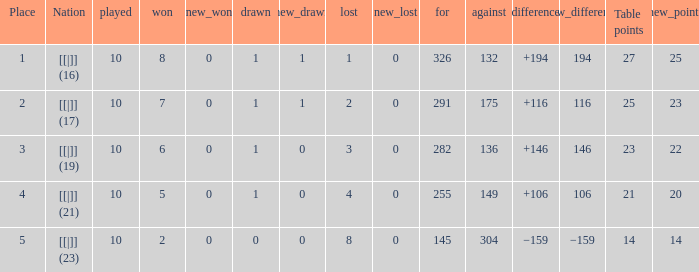 How many table points are listed for the deficit is +194?  1.0. 